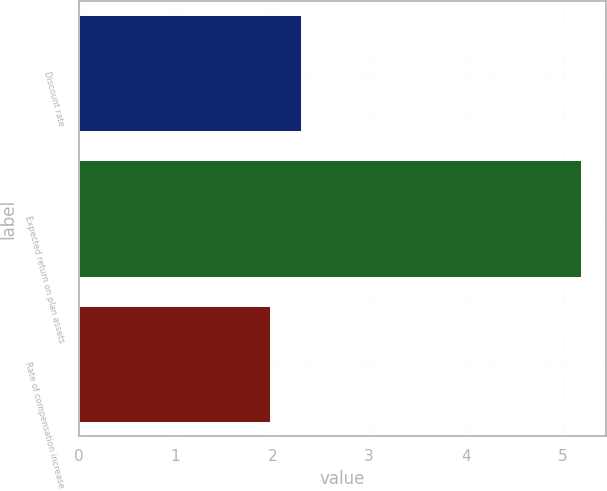Convert chart. <chart><loc_0><loc_0><loc_500><loc_500><bar_chart><fcel>Discount rate<fcel>Expected return on plan assets<fcel>Rate of compensation increase<nl><fcel>2.3<fcel>5.19<fcel>1.98<nl></chart> 